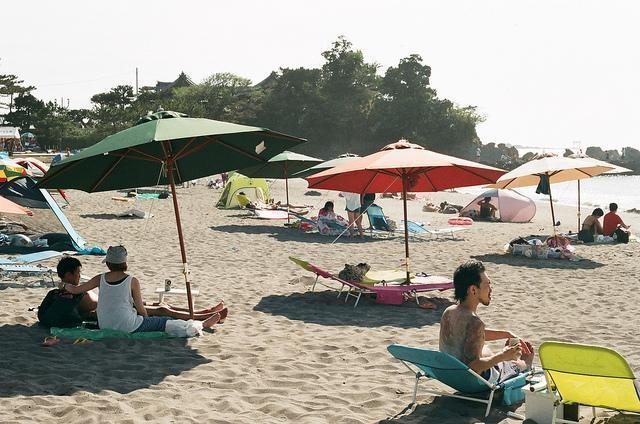How many umbrellas do you see?
Give a very brief answer. 5. How many sun umbrellas are there?
Give a very brief answer. 5. How many people are visible?
Give a very brief answer. 2. How many umbrellas are there?
Give a very brief answer. 3. How many chairs can you see?
Give a very brief answer. 2. How many headlights does this truck have?
Give a very brief answer. 0. 